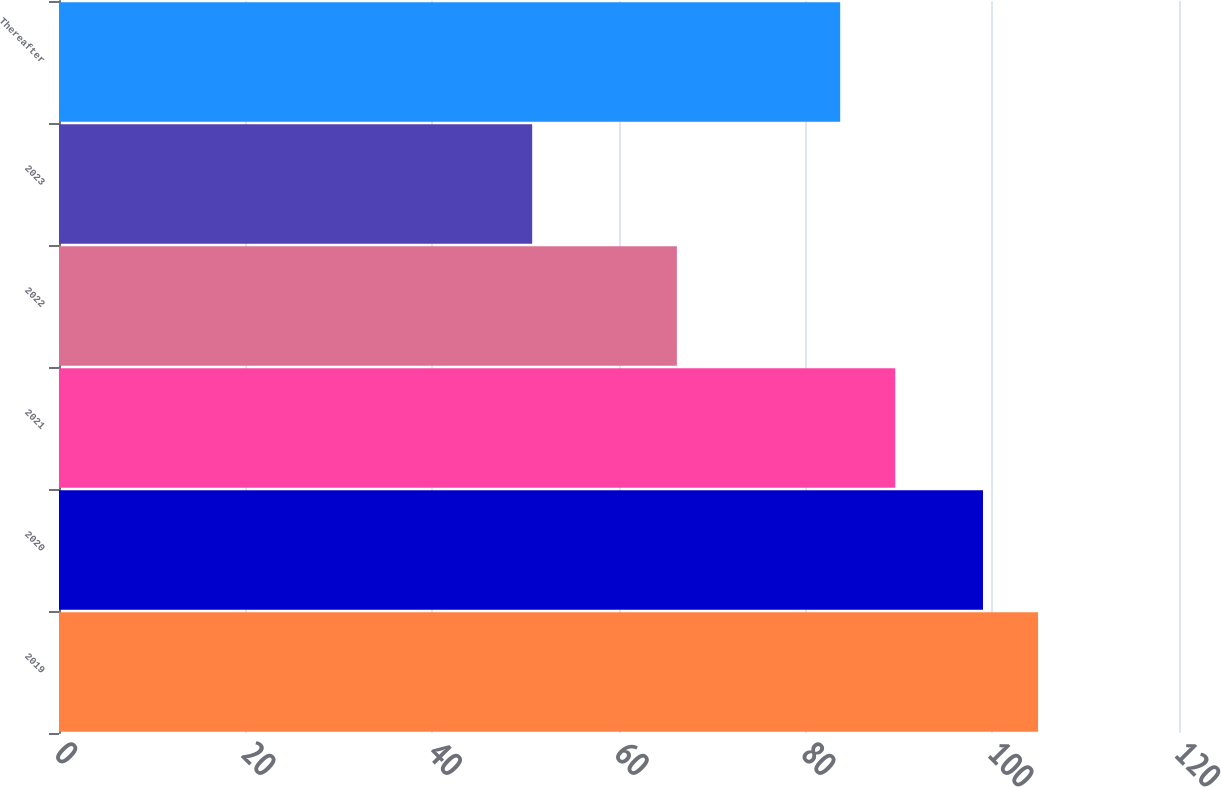Convert chart. <chart><loc_0><loc_0><loc_500><loc_500><bar_chart><fcel>2019<fcel>2020<fcel>2021<fcel>2022<fcel>2023<fcel>Thereafter<nl><fcel>104.9<fcel>99<fcel>89.6<fcel>66.2<fcel>50.7<fcel>83.7<nl></chart> 